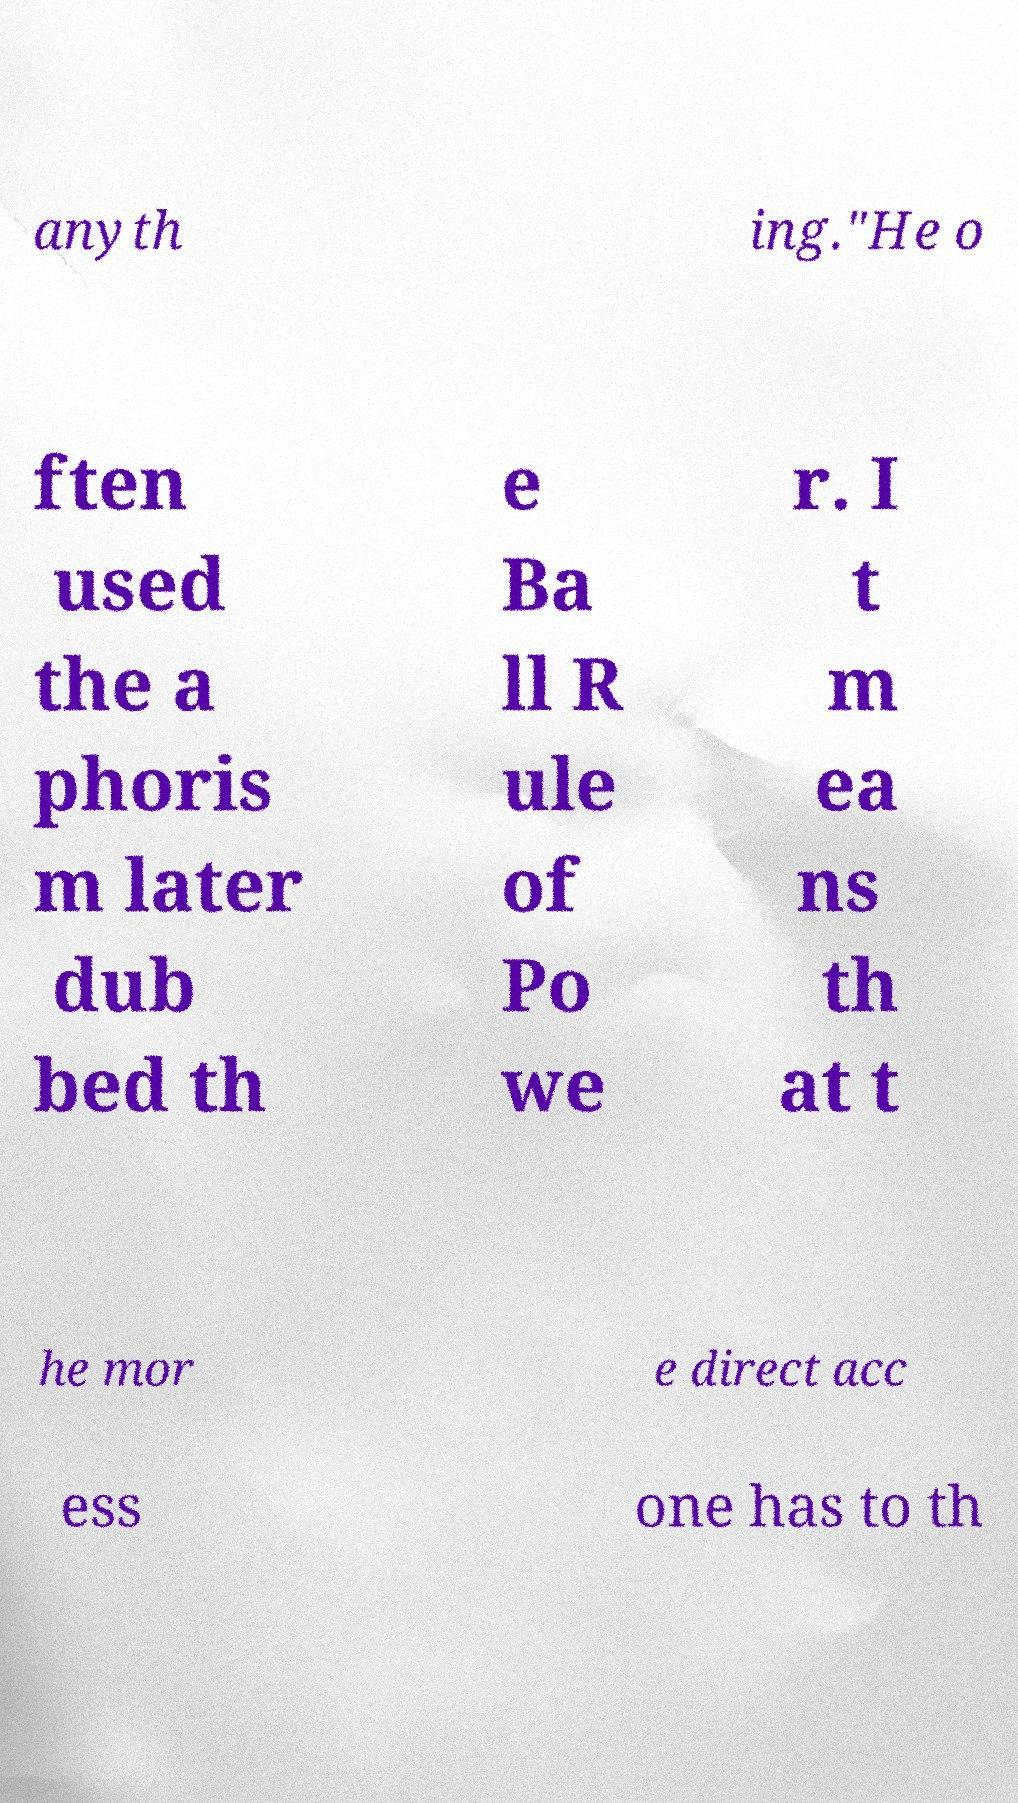What messages or text are displayed in this image? I need them in a readable, typed format. anyth ing."He o ften used the a phoris m later dub bed th e Ba ll R ule of Po we r. I t m ea ns th at t he mor e direct acc ess one has to th 